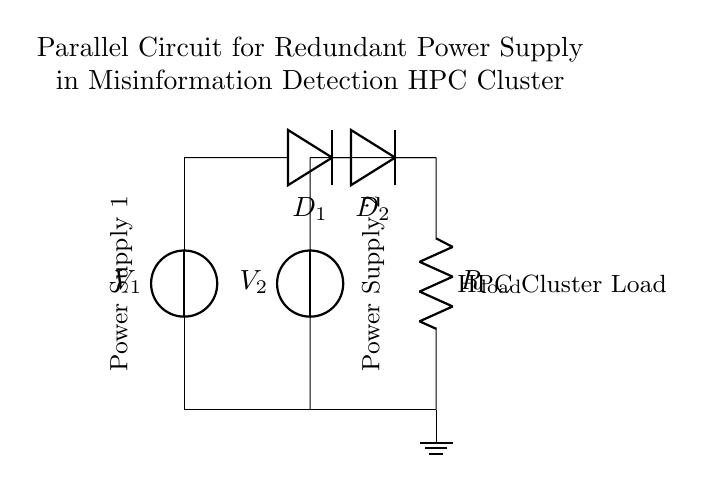What are the two power supplies labeled in the circuit? The two power supplies in the circuit are labeled as V1 and V2. This can be observed at the top left and top middle of the circuit where the voltage sources are depicted.
Answer: V1, V2 What is the component type connected to the load? The component connected to the load is a resistor, as indicated by the symbol and label R_load shown in the diagram. It represents the load the power supplies are driving.
Answer: Resistor How many diodes are used in this circuit? There are two diodes used in this circuit, labeled as D1 and D2, positioned in parallel with the power supplies. Their purpose is to prevent backflow of current should one power supply fail.
Answer: Two What purpose do the diodes serve in this configuration? The diodes serve to isolate the power supplies from one another, ensuring that if one fails, the other can still supply power to the load, thereby maintaining redundancy in the supply circuit. This is crucial for high reliability in HPC applications.
Answer: Isolation What happens to the load current if one power supply fails? If one power supply fails, the other power supply will continue to supply the load without interruption, as the circuit's parallel configuration allows for alternative paths for current flow, sustaining operation.
Answer: Continue operation What is the role of the ground in this circuit? The ground serves as a reference point for the circuit's voltage and provides a common return path for the current flowing through the circuit elements, ensuring stable operation and safety in the system.
Answer: Reference point What type of circuit configuration is used here? The circuit configuration used here is a parallel circuit, which is characterized by multiple paths for current to flow, specifically allowing redundancy in power supply for the HPC cluster.
Answer: Parallel 